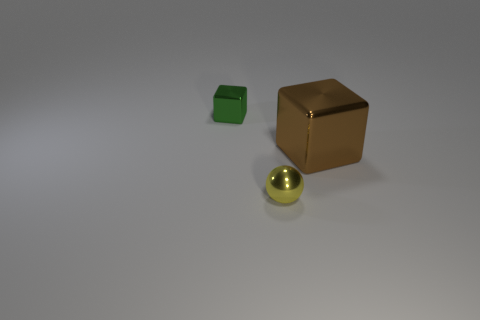What textures are visible on the objects in this image? The cubes exhibit distinct textures; the green cube has a more matte, slightly rough texture characteristic of metal, while the brown cube boasts a reflective, smooth finish akin to polished wood or plastic. The sphere, however, has a glossy texture, suggesting a material like glass or polished metal. 